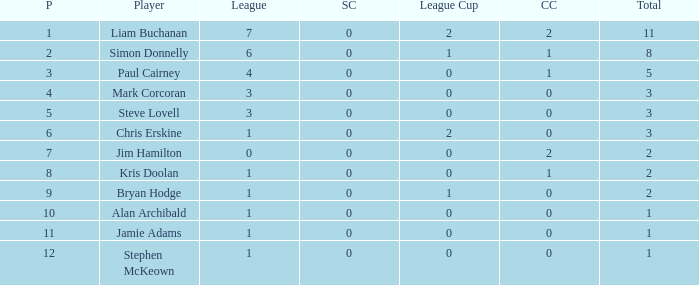What was the lowest number of points scored in the league cup? 0.0. 